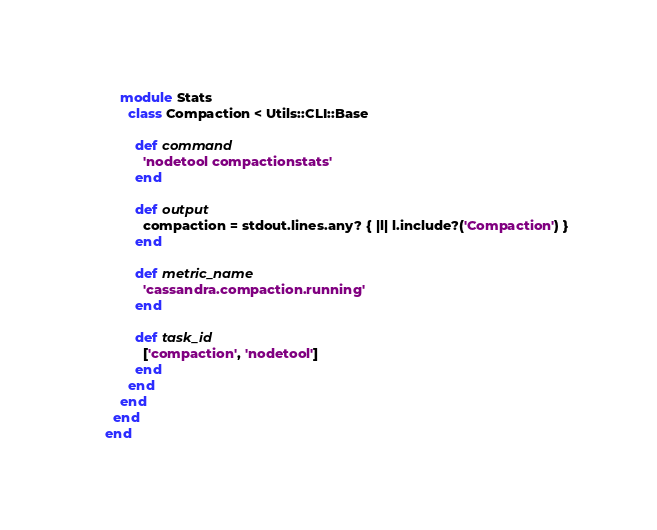Convert code to text. <code><loc_0><loc_0><loc_500><loc_500><_Ruby_>    module Stats
      class Compaction < Utils::CLI::Base

        def command
          'nodetool compactionstats'
        end

        def output
          compaction = stdout.lines.any? { |l| l.include?('Compaction') }
        end

        def metric_name
          'cassandra.compaction.running'
        end

        def task_id
          ['compaction', 'nodetool']
        end
      end
    end
  end
end
</code> 